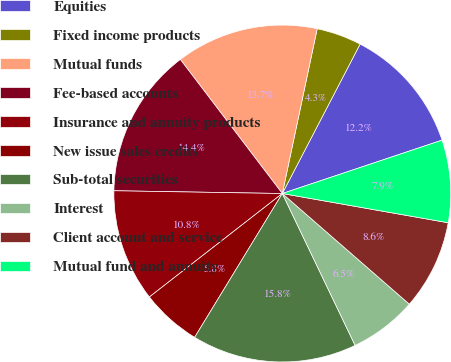Convert chart to OTSL. <chart><loc_0><loc_0><loc_500><loc_500><pie_chart><fcel>Equities<fcel>Fixed income products<fcel>Mutual funds<fcel>Fee-based accounts<fcel>Insurance and annuity products<fcel>New issue sales credits<fcel>Sub-total securities<fcel>Interest<fcel>Client account and service<fcel>Mutual fund and annuity<nl><fcel>12.23%<fcel>4.32%<fcel>13.67%<fcel>14.39%<fcel>10.79%<fcel>5.76%<fcel>15.83%<fcel>6.48%<fcel>8.63%<fcel>7.91%<nl></chart> 